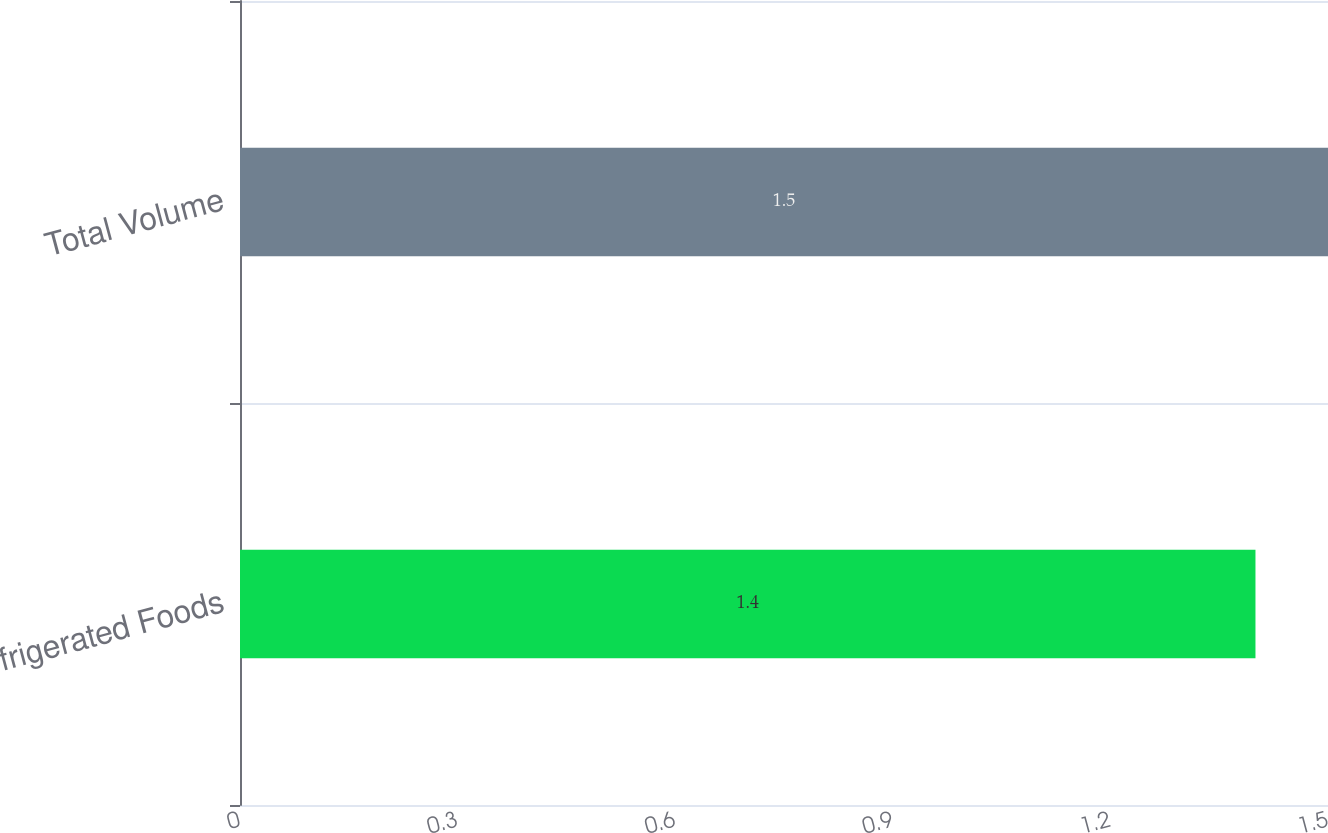<chart> <loc_0><loc_0><loc_500><loc_500><bar_chart><fcel>Refrigerated Foods<fcel>Total Volume<nl><fcel>1.4<fcel>1.5<nl></chart> 